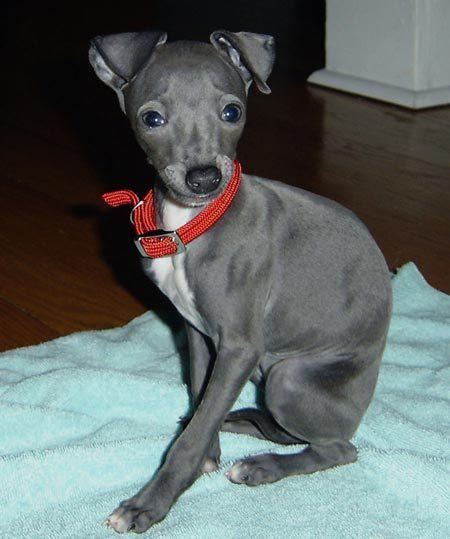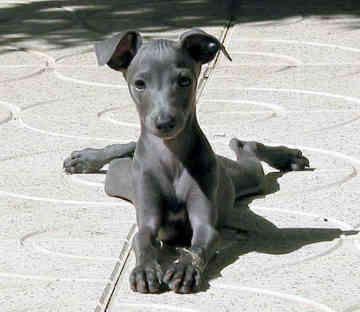The first image is the image on the left, the second image is the image on the right. For the images shown, is this caption "An image shows a hound wearing a collar and sitting upright." true? Answer yes or no. Yes. The first image is the image on the left, the second image is the image on the right. Examine the images to the left and right. Is the description "At least one dog is wearing a collar." accurate? Answer yes or no. Yes. 